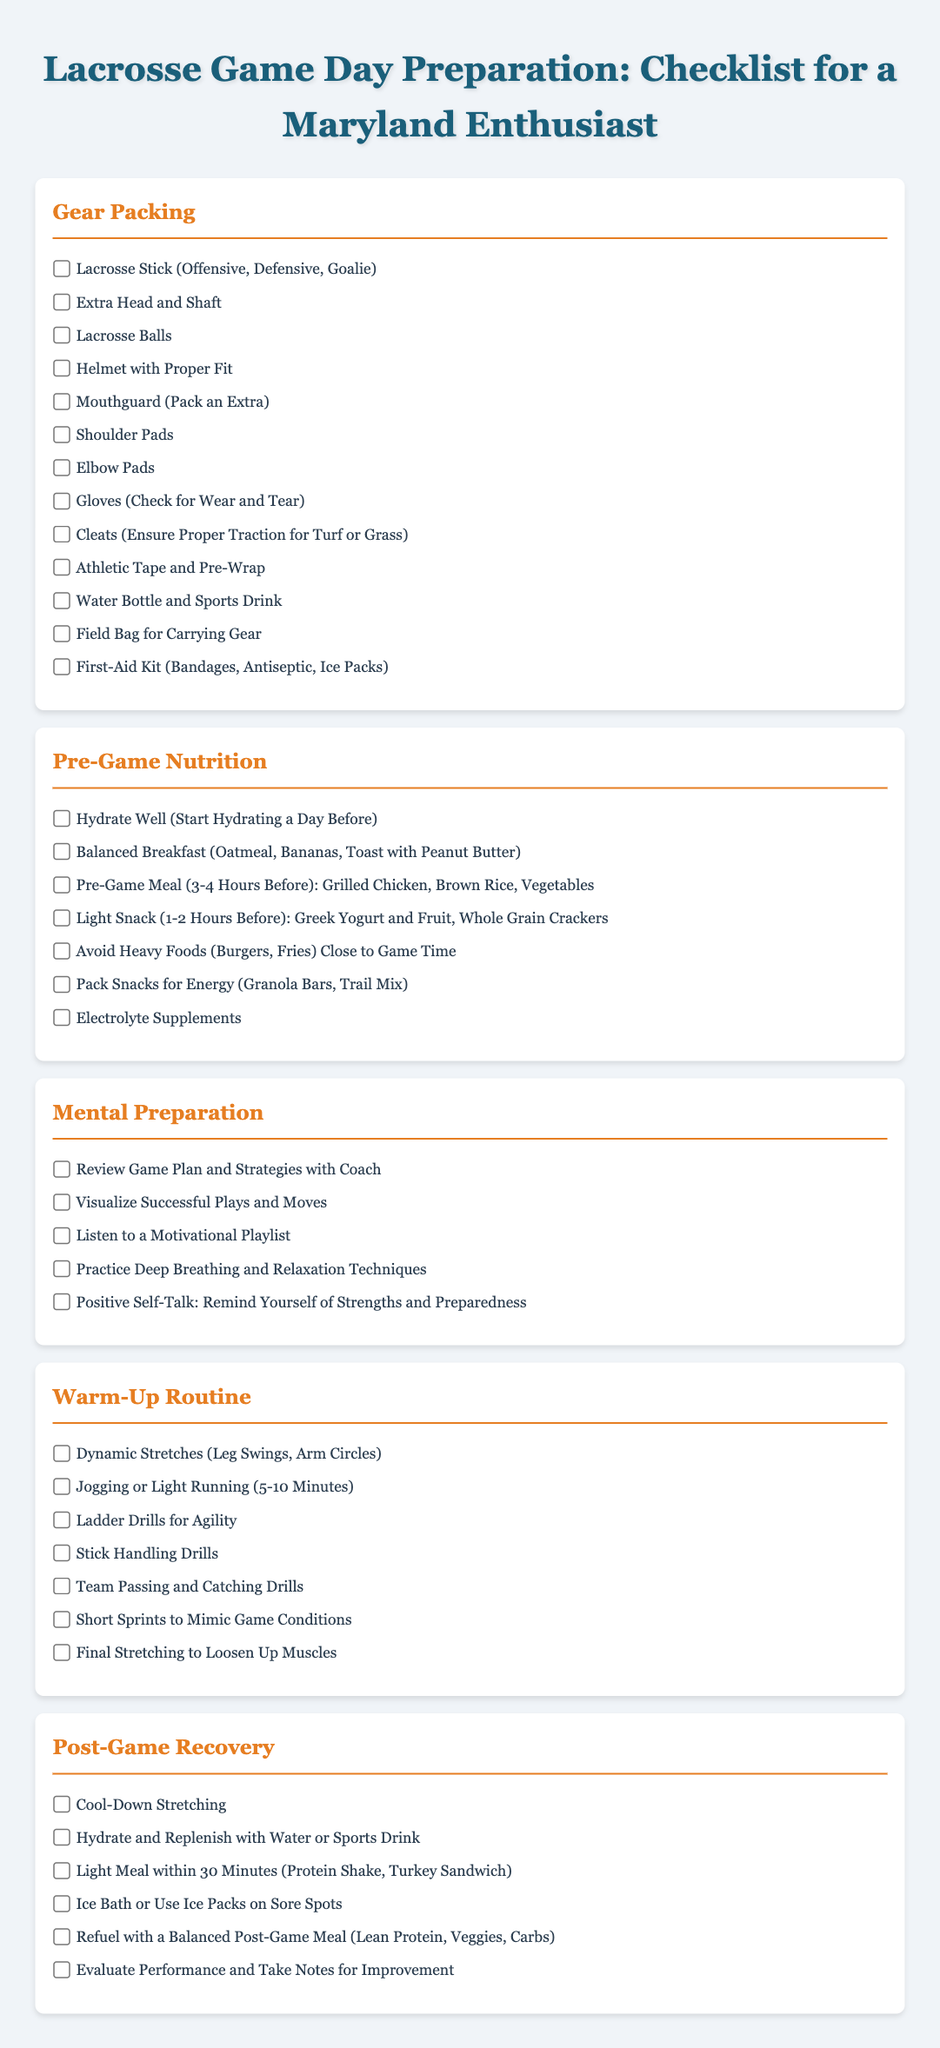what is the first item listed under Gear Packing? The first item listed in the Gear Packing section is the Lacrosse Stick (Offensive, Defensive, Goalie).
Answer: Lacrosse Stick (Offensive, Defensive, Goalie) how many items are there in the Pre-Game Nutrition section? There are a total of 7 items listed in the Pre-Game Nutrition section.
Answer: 7 what should be avoided close to game time according to the checklist? The checklist specifies to avoid heavy foods such as burgers and fries close to game time.
Answer: Heavy Foods (Burgers, Fries) which routine involves dynamic stretches and jogging? The Warm-Up Routine involves dynamic stretches and jogging.
Answer: Warm-Up Routine what is recommended for post-game cooling down? For post-game cooling down, the checklist recommends cool-down stretching.
Answer: Cool-Down Stretching what is the purpose of the hydration mentioned in Pre-Game Nutrition? Hydration is intended to prepare the body for the physical exertion of the game.
Answer: Prepare the body for physical exertion how does the Mental Preparation section relate to performance? The Mental Preparation section focuses on strategies to boost confidence and readiness for performance.
Answer: Boost confidence and readiness 